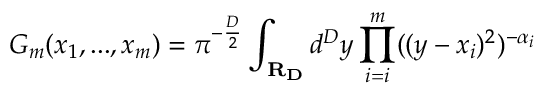Convert formula to latex. <formula><loc_0><loc_0><loc_500><loc_500>G _ { m } ( x _ { 1 } , \dots , x _ { m } ) = \pi ^ { - \frac { D } { 2 } } \int _ { R _ { D } } d ^ { D } y \prod _ { i = i } ^ { m } ( ( y - x _ { i } ) ^ { 2 } ) ^ { - \alpha _ { i } }</formula> 